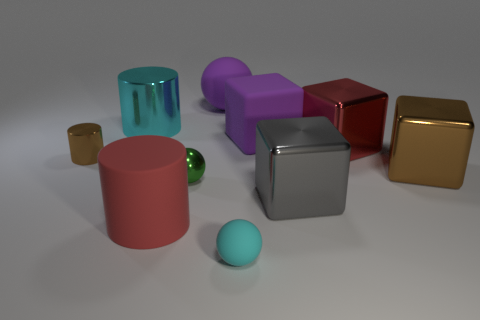Are there any objects that are smaller than the red cylinder? Yes, there are several smaller objects compared to the red cylinder. There's a small brown cube, a very small green sphere, and a smaller cyan-colored cylinder. How many objects in total can you see? I can see a total of eight objects in the image. They vary in shape, size and color. 